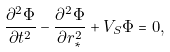<formula> <loc_0><loc_0><loc_500><loc_500>\frac { \partial ^ { 2 } \Phi } { \partial t ^ { 2 } } - \frac { \partial ^ { 2 } \Phi } { \partial r _ { * } ^ { 2 } } + V _ { S } \Phi = 0 ,</formula> 